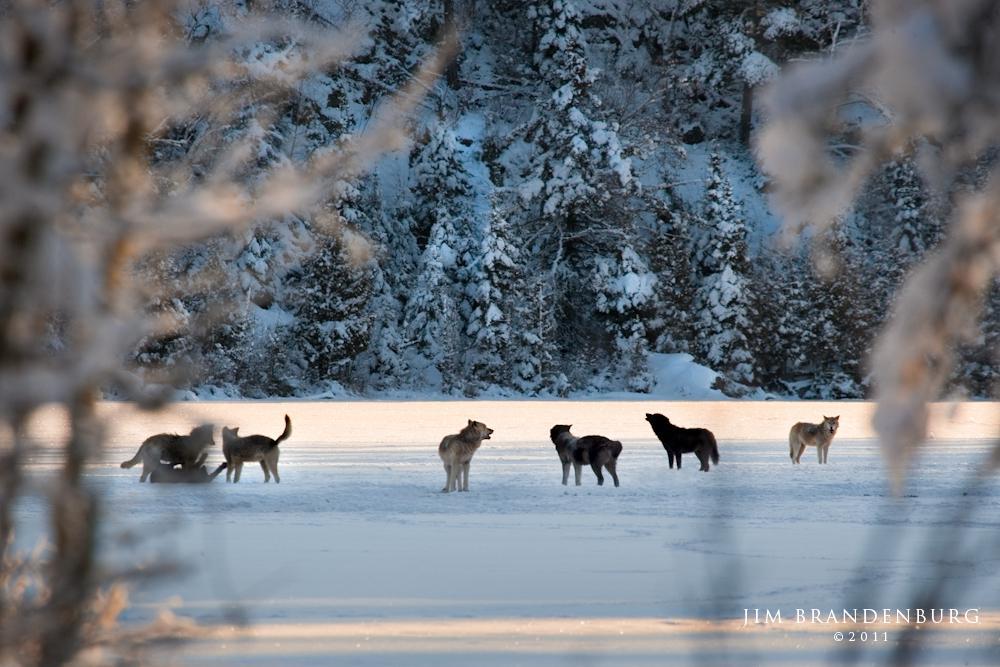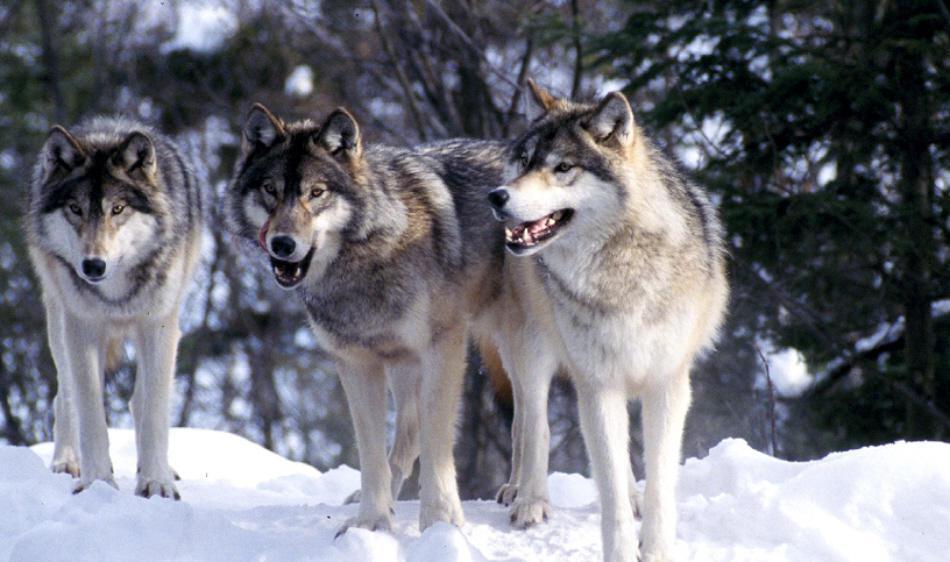The first image is the image on the left, the second image is the image on the right. Given the left and right images, does the statement "There are more animals standing in the image on the left." hold true? Answer yes or no. Yes. The first image is the image on the left, the second image is the image on the right. Assess this claim about the two images: "The left image contains no more than two wolves.". Correct or not? Answer yes or no. No. 